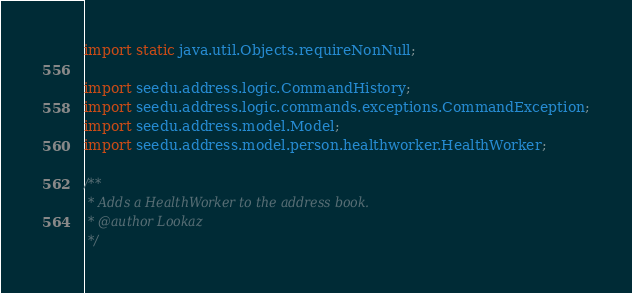<code> <loc_0><loc_0><loc_500><loc_500><_Java_>import static java.util.Objects.requireNonNull;

import seedu.address.logic.CommandHistory;
import seedu.address.logic.commands.exceptions.CommandException;
import seedu.address.model.Model;
import seedu.address.model.person.healthworker.HealthWorker;

/**
 * Adds a HealthWorker to the address book.
 * @author Lookaz
 */</code> 